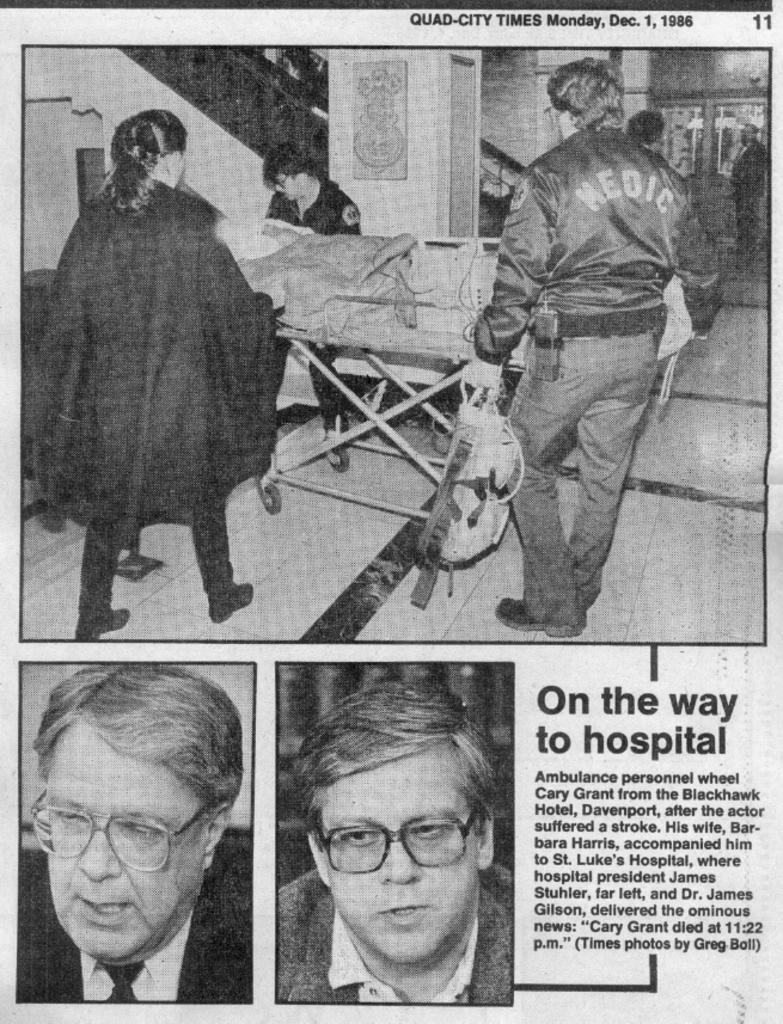Provide a one-sentence caption for the provided image. Newspaper about being on the way to the hospital. 